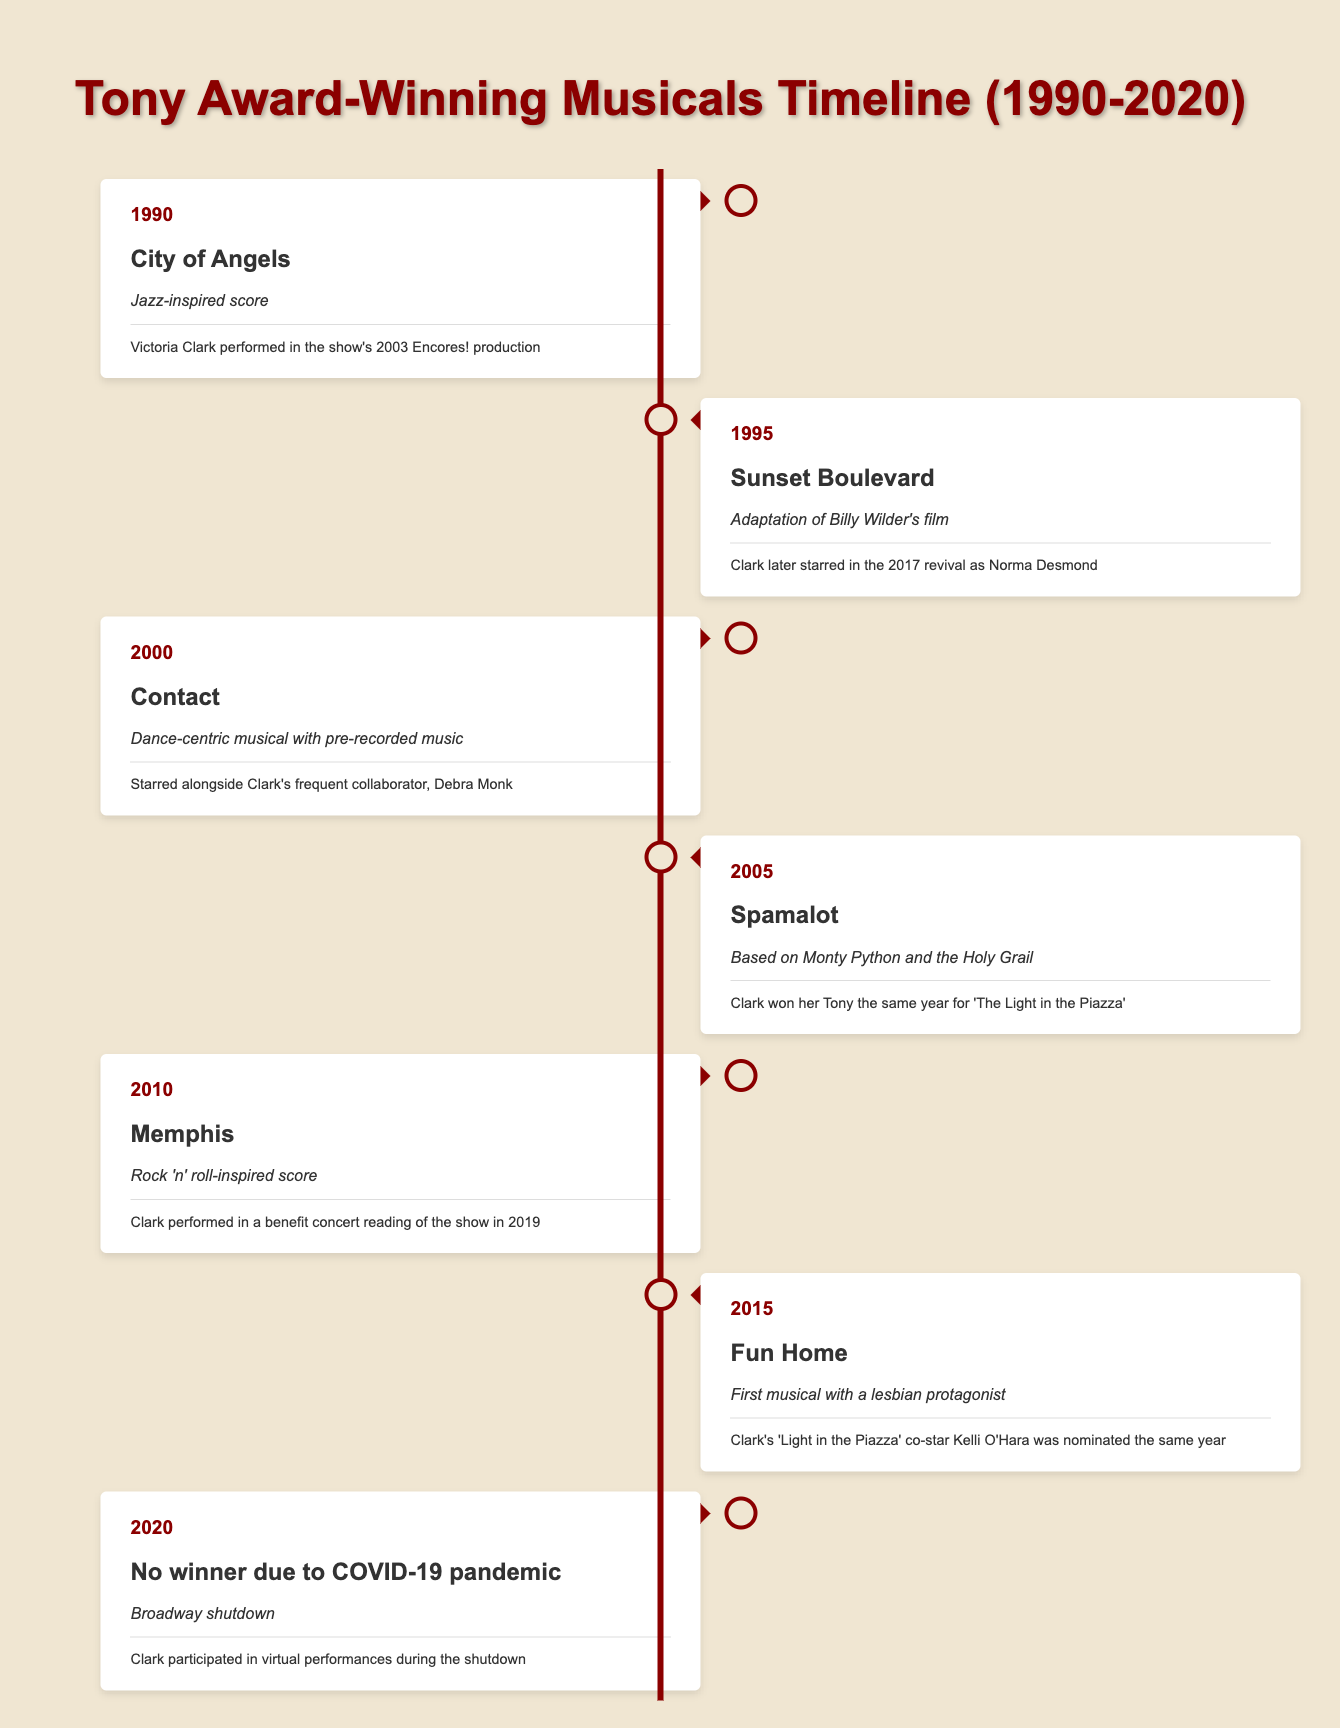What musical won the Tony Award in 2000? The table indicates that "Contact" was the musical that won the Tony Award in 2000.
Answer: Contact What unique feature does the musical "Fun Home" have? According to the table, "Fun Home" is noted as the first musical with a lesbian protagonist.
Answer: First musical with a lesbian protagonist Which year had no Tony Award winner and why? The table states that in 2020 there was no winner due to the COVID-19 pandemic, which caused a Broadway shutdown.
Answer: 2020, COVID-19 pandemic How many years did Victoria Clark have a connection to Tony Award-winning musicals between 1990 and 2020? The years listed in the table where Victoria Clark had connections are 1990, 1995, 2005, 2010, 2015, and 2020, totaling 6 years.
Answer: 6 years Did Victoria Clark win a Tony Award in 2005? The table shows that while Clark won her Tony in 2005 for "The Light in the Piazza," this is distinct from the musical "Spamalot" listed for that year and does not mean she won for that specific musical.
Answer: Yes, but for a different musical In which year did Victoria Clark perform in the benefit concert reading of "Memphis"? According to the table, Victoria Clark performed in a benefit concert reading of "Memphis" in 2019, which is the year specified next to this musical.
Answer: 2019 What notable feature distinguishes the musical "City of Angels"? The table notes that "City of Angels" is characterized by its jazz-inspired score, making this the primary distinguishing feature.
Answer: Jazz-inspired score Which two musicals had a connection to Victoria Clark and were released closest to each other in time? By reviewing the years, "Memphis" (2010) and "Fun Home" (2015) were separated by only 5 years. Both had relevant connections to Clark, making them the closest in terms of release.
Answer: Memphis and Fun Home 